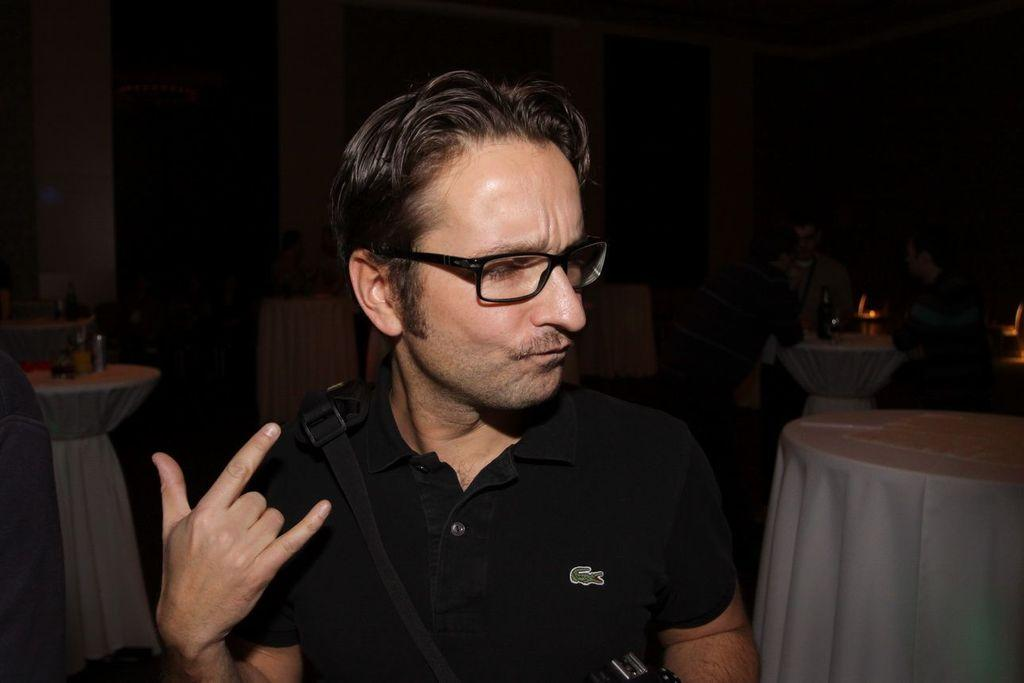Who is present in the image? There is a man in the image. What can be seen on the tables in the image? Tables covered with clothes and objects are visible in the image. What are the people in the image doing? There are people sitting in the image. What type of poison is being used to clean the clothes in the image? There is no mention of poison or cleaning in the image; the tables are covered with clothes and objects, and people are sitting. 